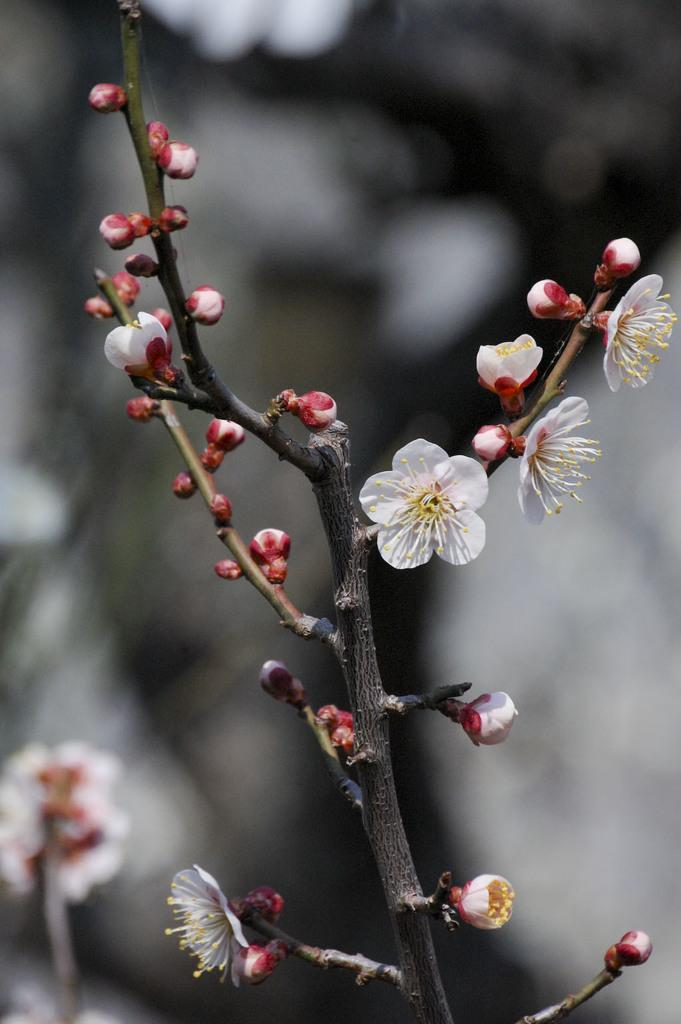What is present on the branch of the tree in the image? There are flowers and buds on the branch of the tree in the image. Can you describe the appearance of the background in the image? The background appears blurry in the image. What type of pies are being rewarded for their tendency to grow in the image? There are no pies present in the image, and the image does not depict any rewards or tendencies related to growing. 